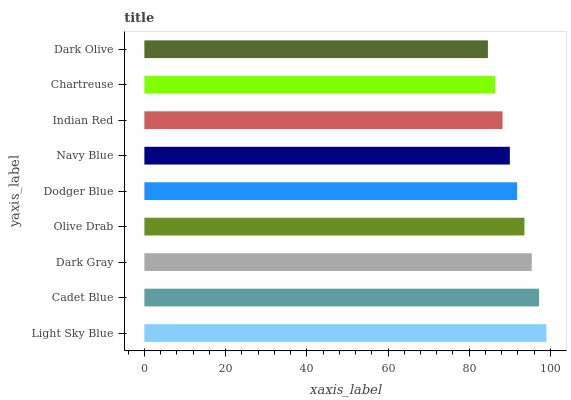Is Dark Olive the minimum?
Answer yes or no. Yes. Is Light Sky Blue the maximum?
Answer yes or no. Yes. Is Cadet Blue the minimum?
Answer yes or no. No. Is Cadet Blue the maximum?
Answer yes or no. No. Is Light Sky Blue greater than Cadet Blue?
Answer yes or no. Yes. Is Cadet Blue less than Light Sky Blue?
Answer yes or no. Yes. Is Cadet Blue greater than Light Sky Blue?
Answer yes or no. No. Is Light Sky Blue less than Cadet Blue?
Answer yes or no. No. Is Dodger Blue the high median?
Answer yes or no. Yes. Is Dodger Blue the low median?
Answer yes or no. Yes. Is Chartreuse the high median?
Answer yes or no. No. Is Navy Blue the low median?
Answer yes or no. No. 